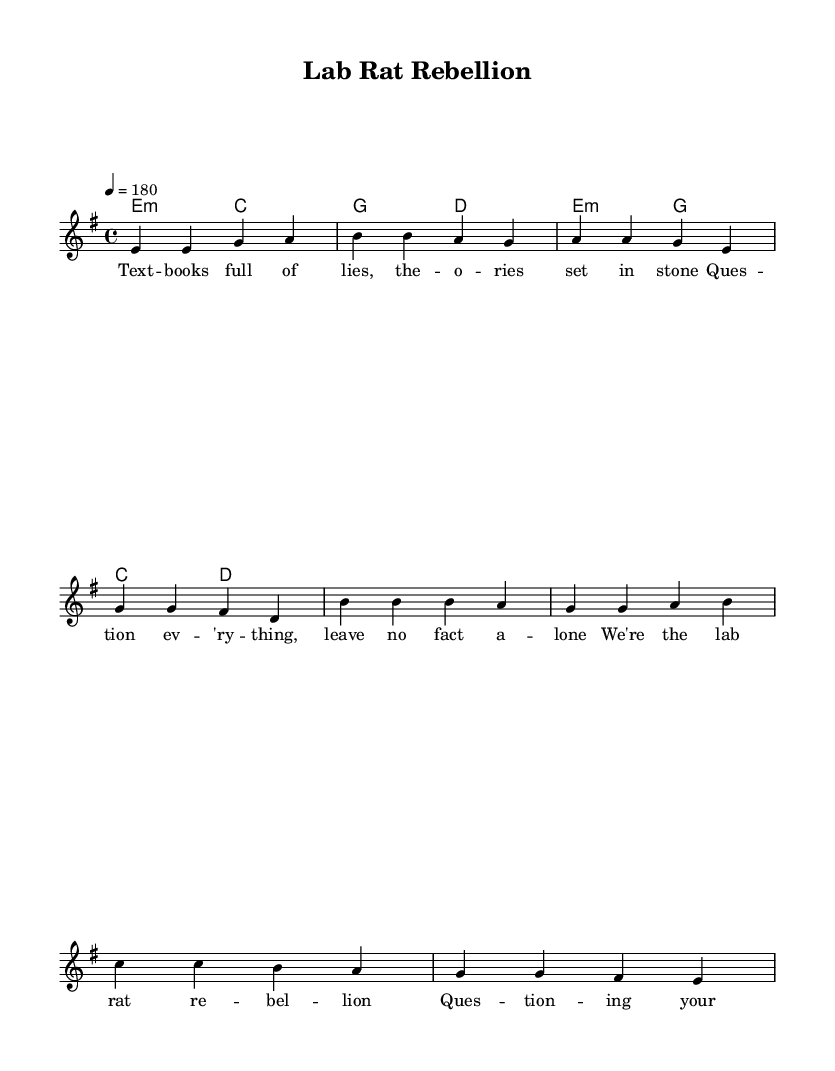What is the key signature of this music? The key signature is E minor, which has one sharp (F#) indicated on the staff.
Answer: E minor What is the time signature of this music? The time signature is 4/4, which can be indicated by the four beats per measure.
Answer: 4/4 What is the tempo marking of this piece? The tempo marking is indicated as 4 = 180, which refers to the quarter note being counted at 180 beats per minute.
Answer: 180 How many measures are in the verse section? The verse section consists of 4 measures, as seen in the melodic and harmonic sections presented.
Answer: 4 What is the main theme of the lyrics? The lyrics critique the established scientific theories and encourage questioning everything that has been taught, emphasizing rebellion against conformity in academia.
Answer: Rebellion against conformity What is the chord progression of the chorus? The chord progression in the chorus is E minor, G major, C major, and D major, creating a contrast with the verse chords.
Answer: E minor, G major, C major, D major What does the phrase "Lab Rat Rebellion" symbolize in the context of the punk genre? The phrase symbolizes the struggle and revolt against the rigid academic establishment, reflecting the punk ethos of questioning authority and norms.
Answer: Struggle against authority 